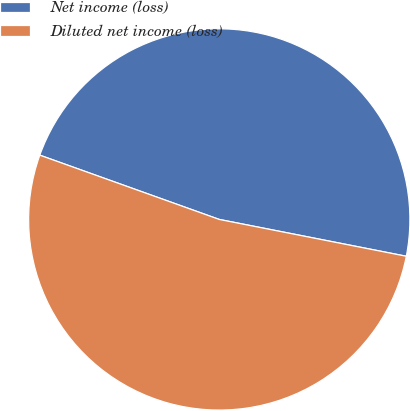<chart> <loc_0><loc_0><loc_500><loc_500><pie_chart><fcel>Net income (loss)<fcel>Diluted net income (loss)<nl><fcel>47.62%<fcel>52.38%<nl></chart> 